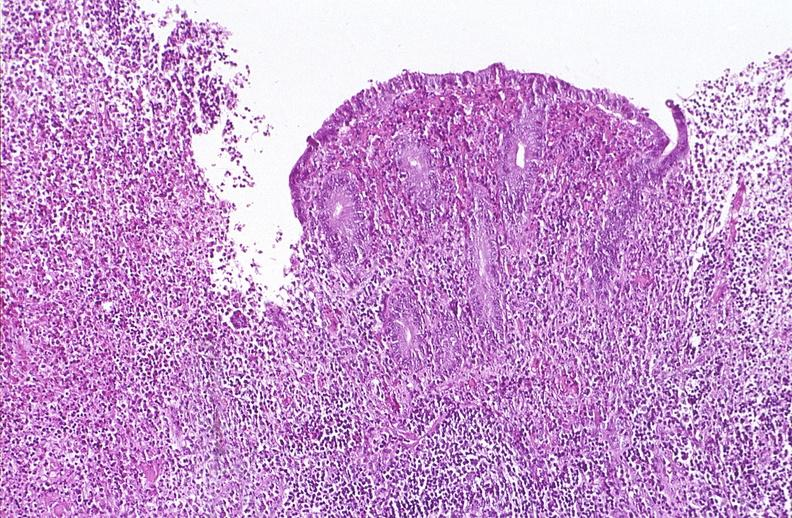what does this image show?
Answer the question using a single word or phrase. Appendix 